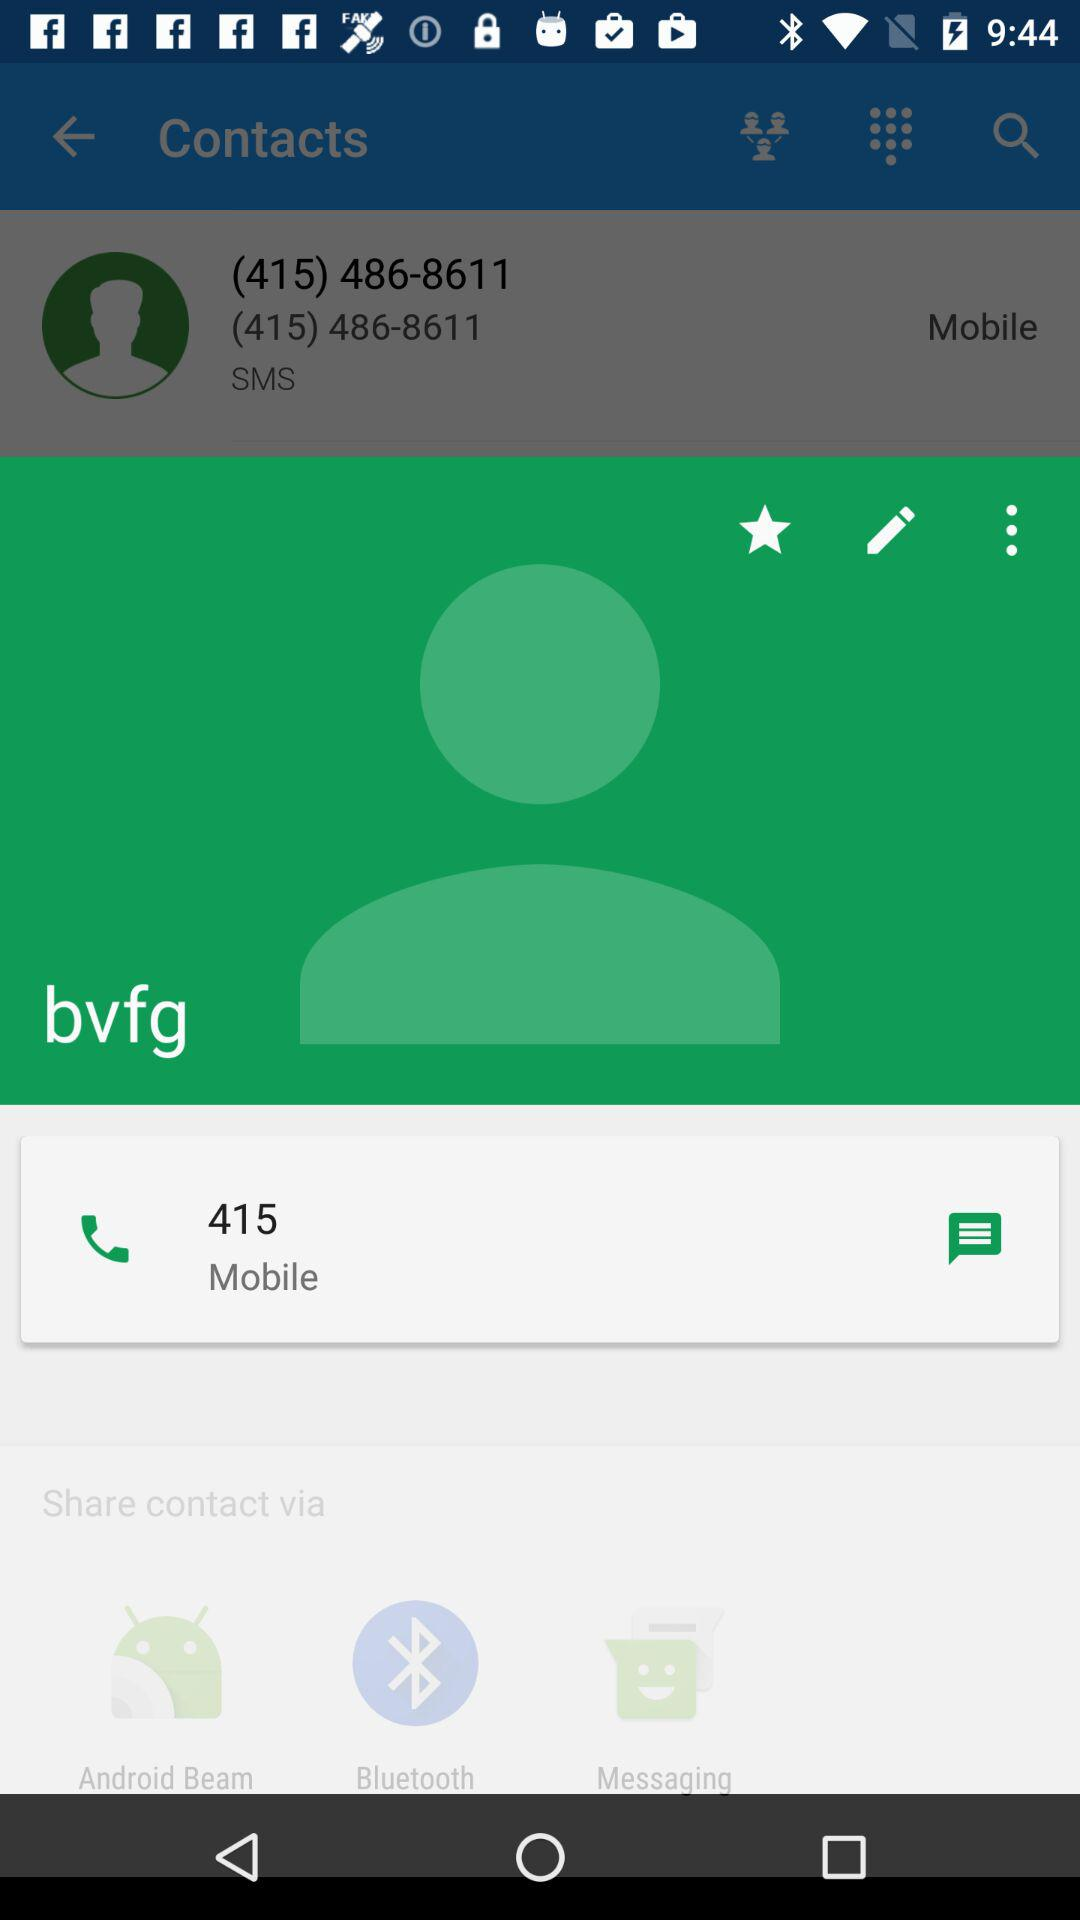How many more share options are there than edit options?
Answer the question using a single word or phrase. 2 